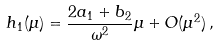Convert formula to latex. <formula><loc_0><loc_0><loc_500><loc_500>h _ { 1 } ( \mu ) = \frac { 2 a _ { 1 } + b _ { 2 } } { \omega ^ { 2 } } \mu + O ( \mu ^ { 2 } ) \, ,</formula> 